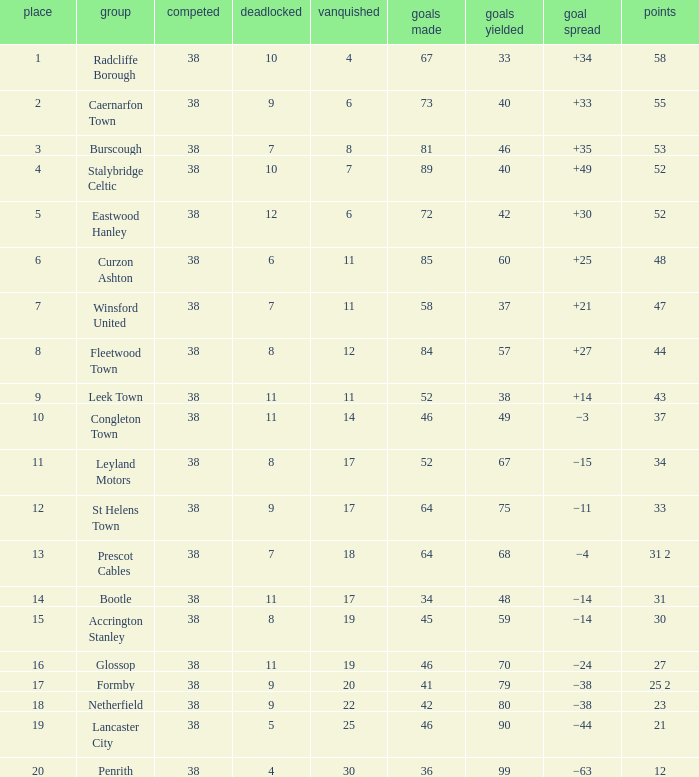WHAT IS THE POSITION WITH A LOST OF 6, FOR CAERNARFON TOWN? 2.0. 